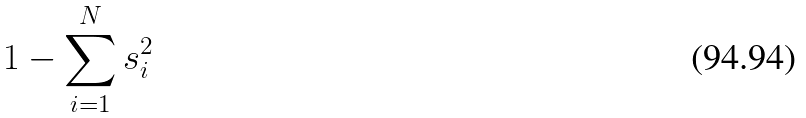<formula> <loc_0><loc_0><loc_500><loc_500>1 - \sum _ { i = 1 } ^ { N } s _ { i } ^ { 2 }</formula> 